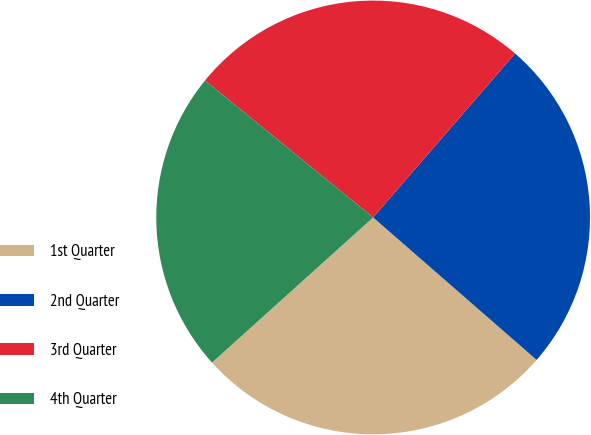Convert chart to OTSL. <chart><loc_0><loc_0><loc_500><loc_500><pie_chart><fcel>1st Quarter<fcel>2nd Quarter<fcel>3rd Quarter<fcel>4th Quarter<nl><fcel>26.92%<fcel>25.05%<fcel>25.48%<fcel>22.55%<nl></chart> 